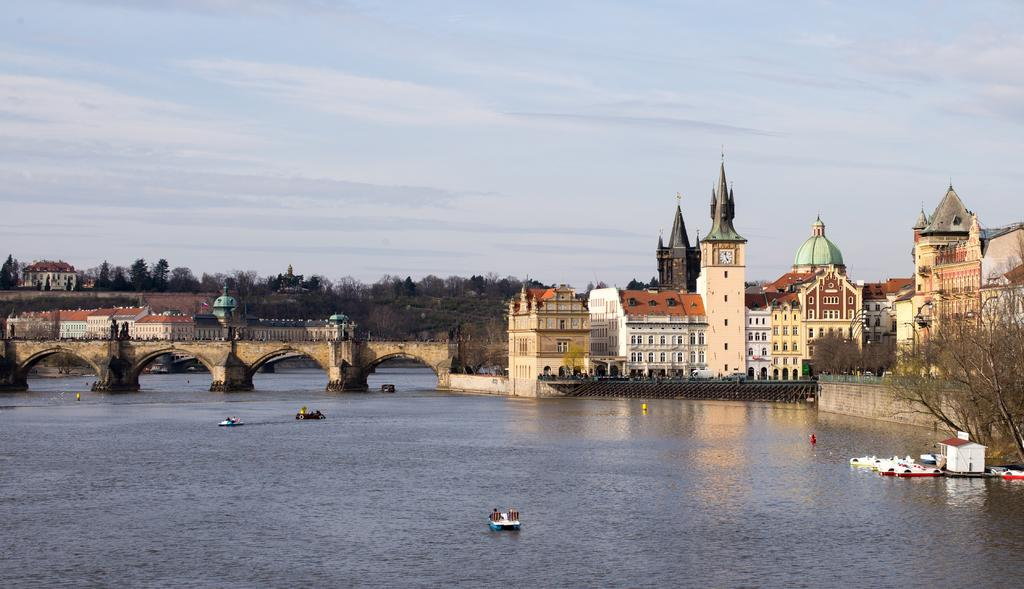What is located on the river in the image? There are boats on the river in the image. What type of structures can be seen in the image? There are buildings visible in the image. What type of vegetation is present in the image? Trees are present in the image. What connects the two sides of the river in the image? There is a bridge in the image. What is visible above the structures and vegetation in the image? The sky is visible in the image. Where is the lunchroom located in the image? There is no lunchroom present in the image. What type of porter is assisting with the boats in the image? There is no porter present in the image, and the boats do not require assistance. 